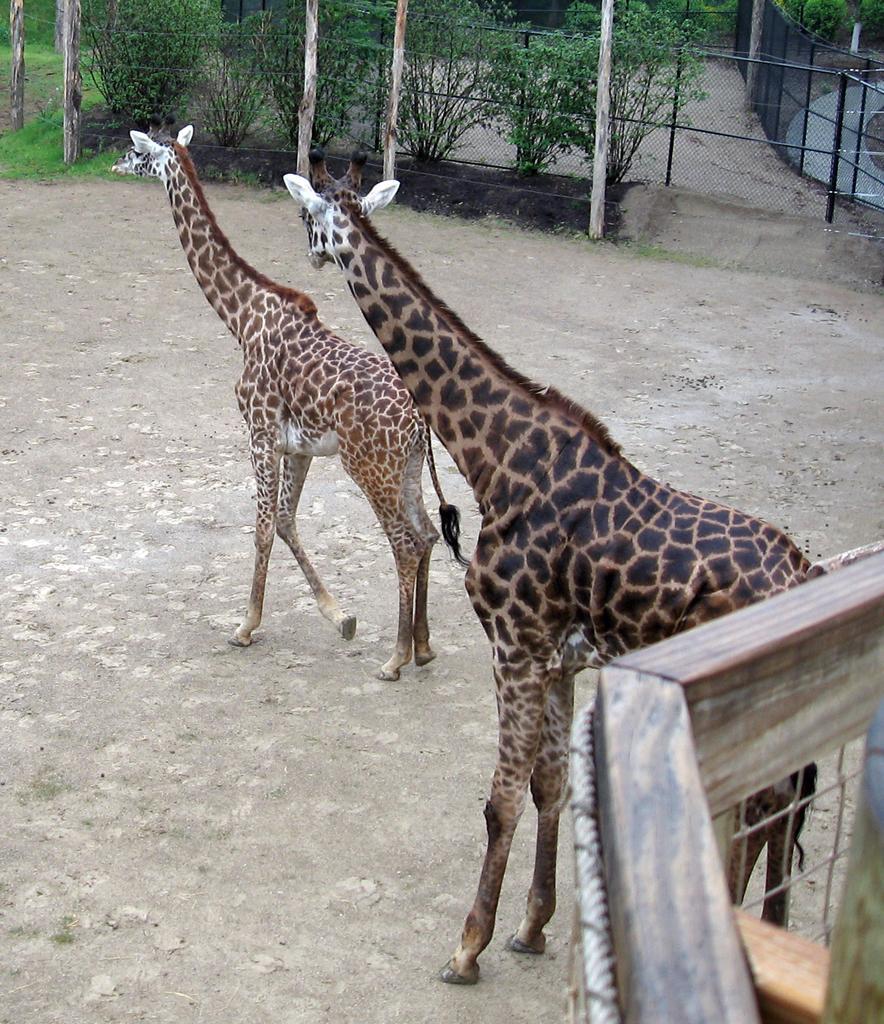Please provide a concise description of this image. In this picture we can see two giraffes standing on the path. We can see some fencing from left to right. There are few poles and trees in the background. 